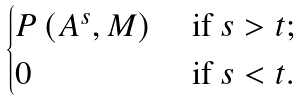<formula> <loc_0><loc_0><loc_500><loc_500>\begin{cases} P \left ( A ^ { s } , M \right ) & { \text { if} } \ s > t ; \\ 0 & { \text { if} } \ s < t . \\ \end{cases}</formula> 